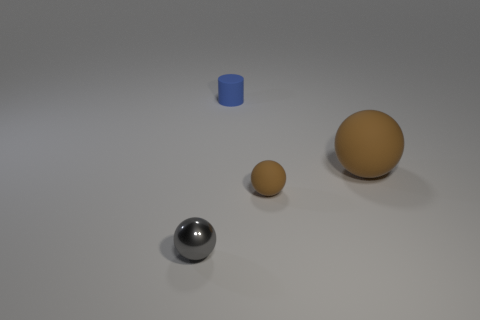What number of things are the same color as the big rubber ball?
Make the answer very short. 1. There is a rubber thing that is behind the large object; are there any things that are left of it?
Your answer should be very brief. Yes. How many tiny things are both in front of the small rubber sphere and to the right of the gray shiny sphere?
Your answer should be very brief. 0. How many blue things have the same material as the tiny blue cylinder?
Your answer should be compact. 0. There is a matte object left of the matte ball to the left of the large brown rubber sphere; what is its size?
Your answer should be very brief. Small. Are there any large brown matte things that have the same shape as the small brown rubber object?
Your answer should be very brief. Yes. There is a object left of the tiny blue thing; is it the same size as the rubber thing that is to the left of the tiny brown matte thing?
Your answer should be compact. Yes. Is the number of small matte things that are on the right side of the gray metallic object less than the number of things in front of the tiny cylinder?
Give a very brief answer. Yes. There is a ball that is the same color as the big object; what is its material?
Ensure brevity in your answer.  Rubber. What is the color of the matte ball to the left of the large thing?
Keep it short and to the point. Brown. 